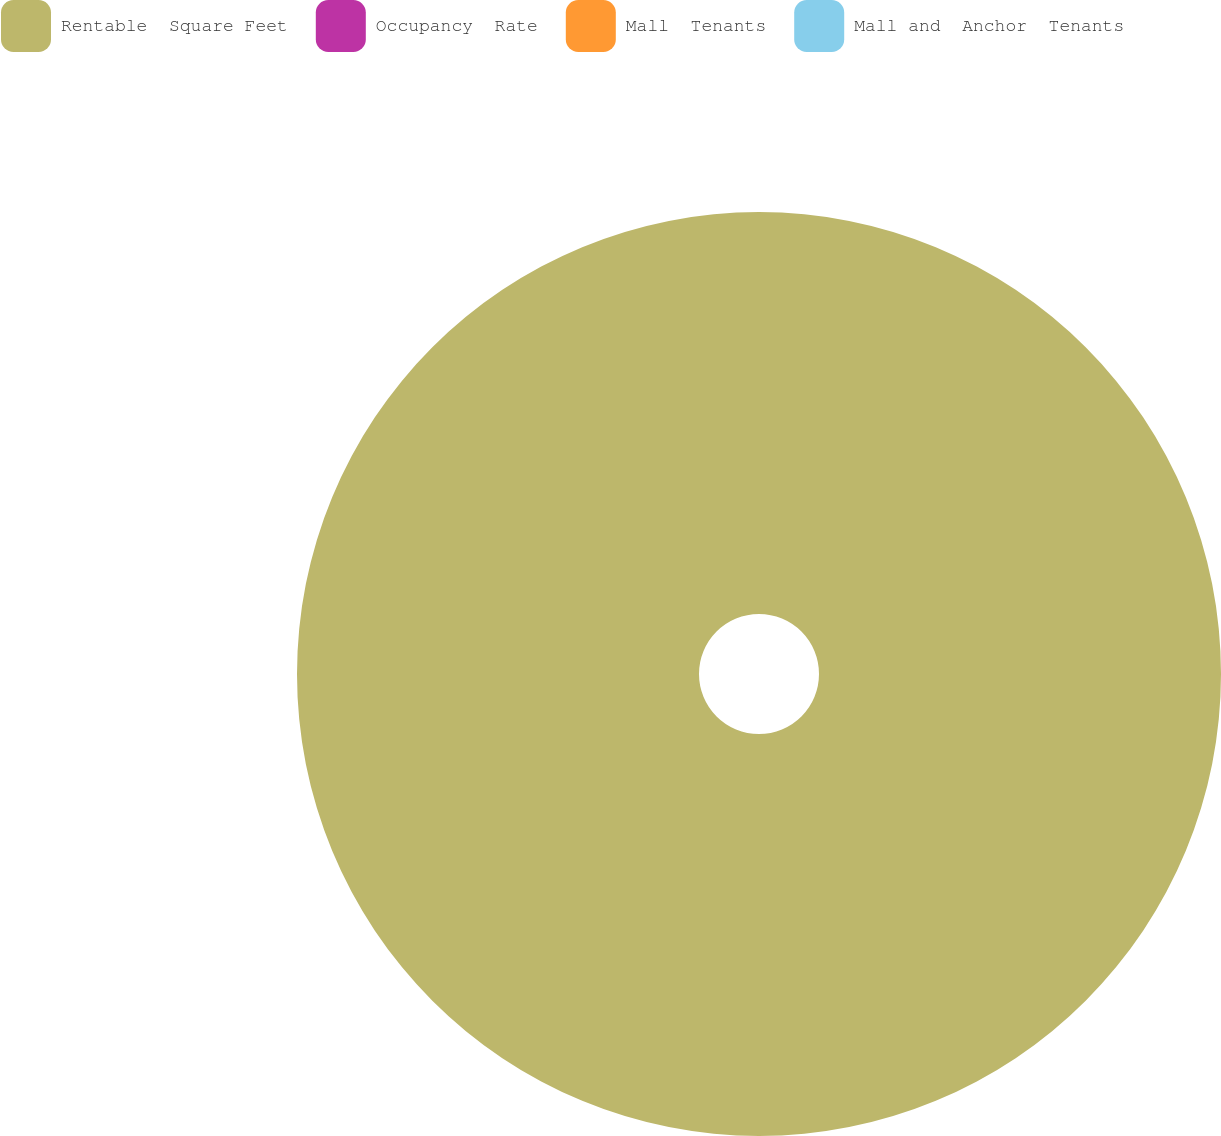Convert chart. <chart><loc_0><loc_0><loc_500><loc_500><pie_chart><fcel>Rentable  Square Feet<fcel>Occupancy  Rate<fcel>Mall  Tenants<fcel>Mall and  Anchor  Tenants<nl><fcel>100.0%<fcel>0.0%<fcel>0.0%<fcel>0.0%<nl></chart> 